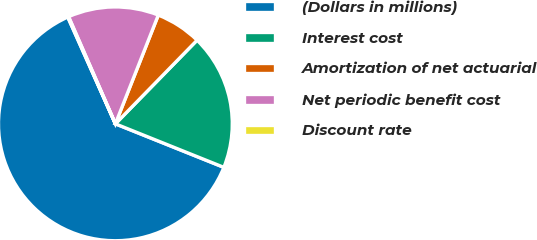<chart> <loc_0><loc_0><loc_500><loc_500><pie_chart><fcel>(Dollars in millions)<fcel>Interest cost<fcel>Amortization of net actuarial<fcel>Net periodic benefit cost<fcel>Discount rate<nl><fcel>62.25%<fcel>18.76%<fcel>6.33%<fcel>12.54%<fcel>0.12%<nl></chart> 